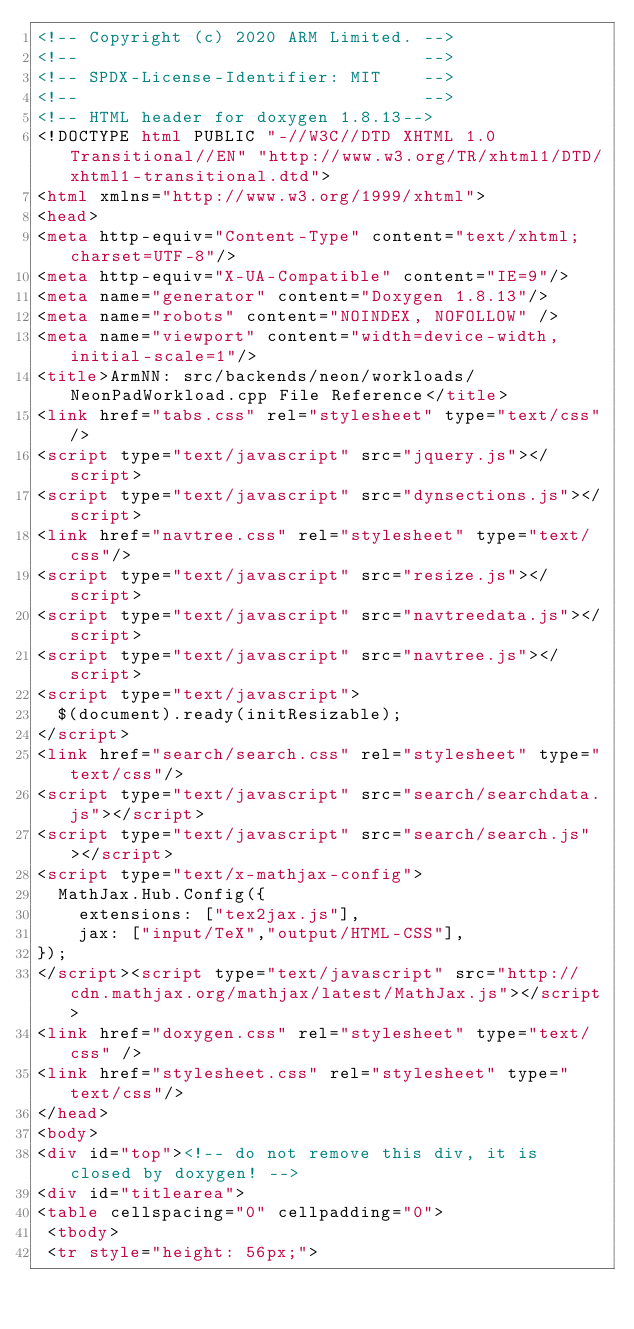<code> <loc_0><loc_0><loc_500><loc_500><_HTML_><!-- Copyright (c) 2020 ARM Limited. -->
<!--                                 -->
<!-- SPDX-License-Identifier: MIT    -->
<!--                                 -->
<!-- HTML header for doxygen 1.8.13-->
<!DOCTYPE html PUBLIC "-//W3C//DTD XHTML 1.0 Transitional//EN" "http://www.w3.org/TR/xhtml1/DTD/xhtml1-transitional.dtd">
<html xmlns="http://www.w3.org/1999/xhtml">
<head>
<meta http-equiv="Content-Type" content="text/xhtml;charset=UTF-8"/>
<meta http-equiv="X-UA-Compatible" content="IE=9"/>
<meta name="generator" content="Doxygen 1.8.13"/>
<meta name="robots" content="NOINDEX, NOFOLLOW" />
<meta name="viewport" content="width=device-width, initial-scale=1"/>
<title>ArmNN: src/backends/neon/workloads/NeonPadWorkload.cpp File Reference</title>
<link href="tabs.css" rel="stylesheet" type="text/css"/>
<script type="text/javascript" src="jquery.js"></script>
<script type="text/javascript" src="dynsections.js"></script>
<link href="navtree.css" rel="stylesheet" type="text/css"/>
<script type="text/javascript" src="resize.js"></script>
<script type="text/javascript" src="navtreedata.js"></script>
<script type="text/javascript" src="navtree.js"></script>
<script type="text/javascript">
  $(document).ready(initResizable);
</script>
<link href="search/search.css" rel="stylesheet" type="text/css"/>
<script type="text/javascript" src="search/searchdata.js"></script>
<script type="text/javascript" src="search/search.js"></script>
<script type="text/x-mathjax-config">
  MathJax.Hub.Config({
    extensions: ["tex2jax.js"],
    jax: ["input/TeX","output/HTML-CSS"],
});
</script><script type="text/javascript" src="http://cdn.mathjax.org/mathjax/latest/MathJax.js"></script>
<link href="doxygen.css" rel="stylesheet" type="text/css" />
<link href="stylesheet.css" rel="stylesheet" type="text/css"/>
</head>
<body>
<div id="top"><!-- do not remove this div, it is closed by doxygen! -->
<div id="titlearea">
<table cellspacing="0" cellpadding="0">
 <tbody>
 <tr style="height: 56px;"></code> 